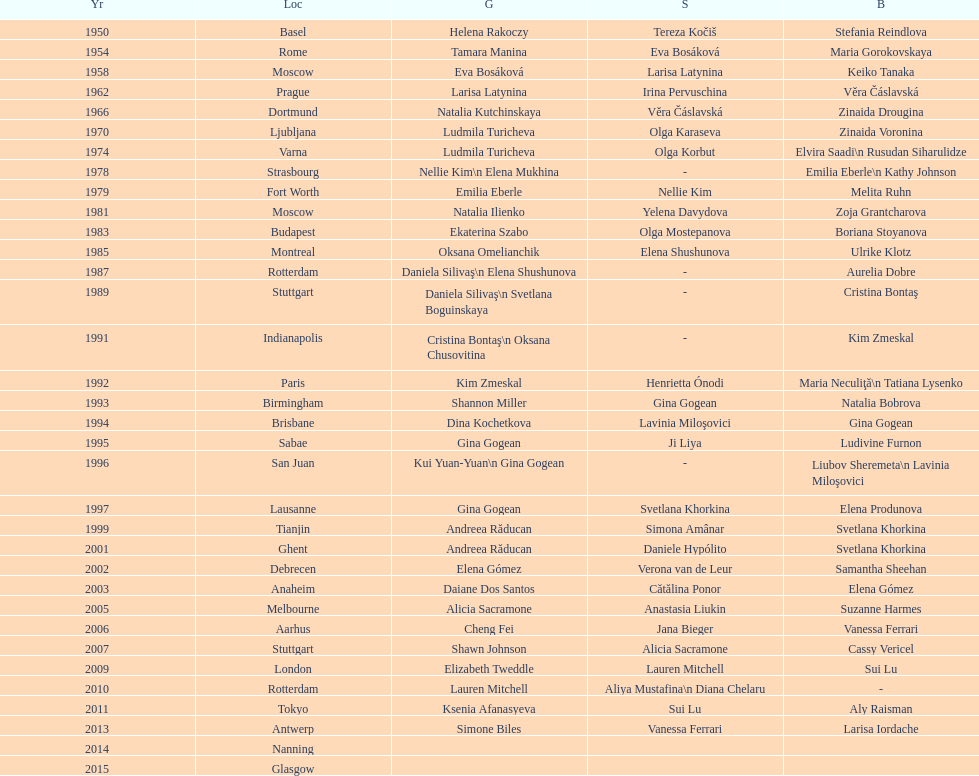What is the total number of russian gymnasts that have won silver. 8. 